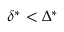<formula> <loc_0><loc_0><loc_500><loc_500>\delta ^ { * } < \Delta ^ { * }</formula> 